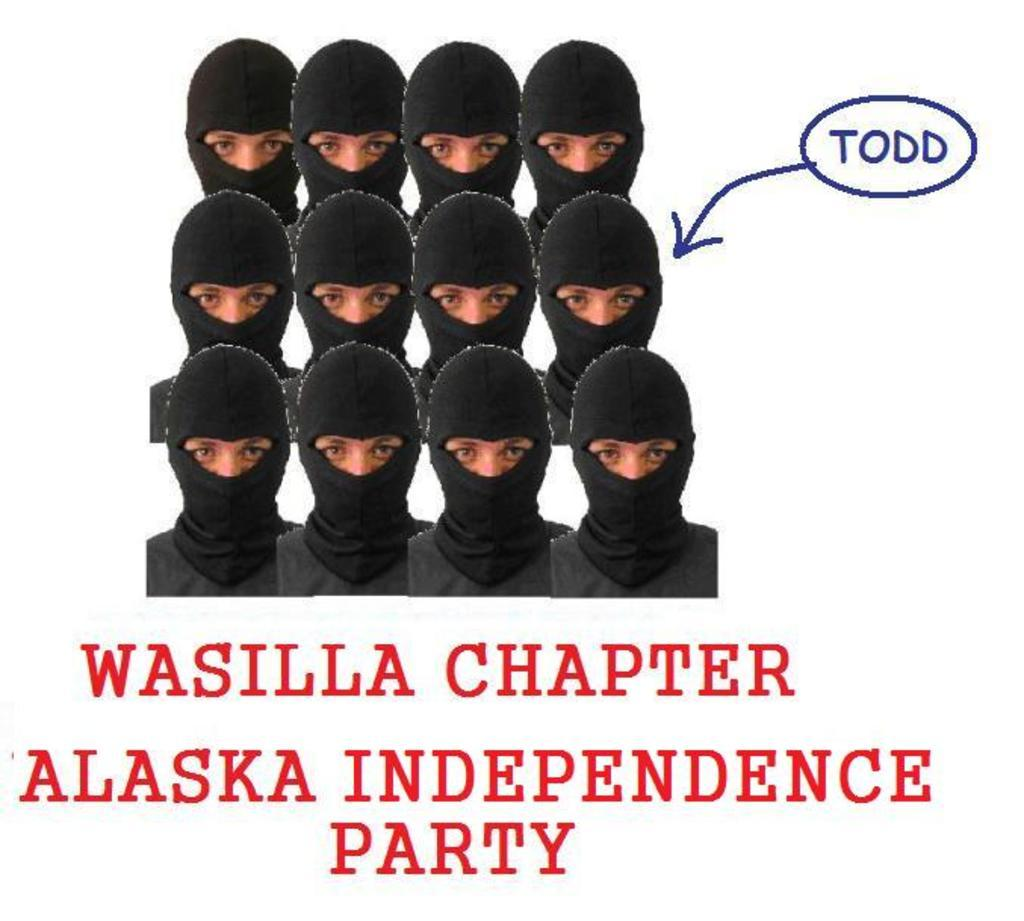What is the main subject of the image? There is a picture of a person in the image. What is the person wearing in the image? The person is wearing a mask in the image. Are there any words or letters in the image? Yes, there is text present in the image. What type of creature is hiding behind the person in the image? There is no creature present in the image; it only features a picture of a person wearing a mask and text. 